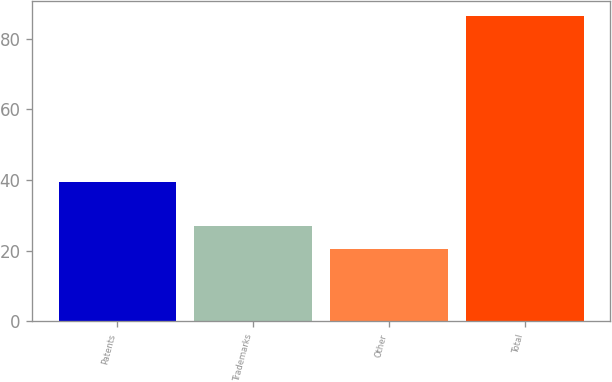<chart> <loc_0><loc_0><loc_500><loc_500><bar_chart><fcel>Patents<fcel>Trademarks<fcel>Other<fcel>Total<nl><fcel>39.4<fcel>27<fcel>20.4<fcel>86.4<nl></chart> 